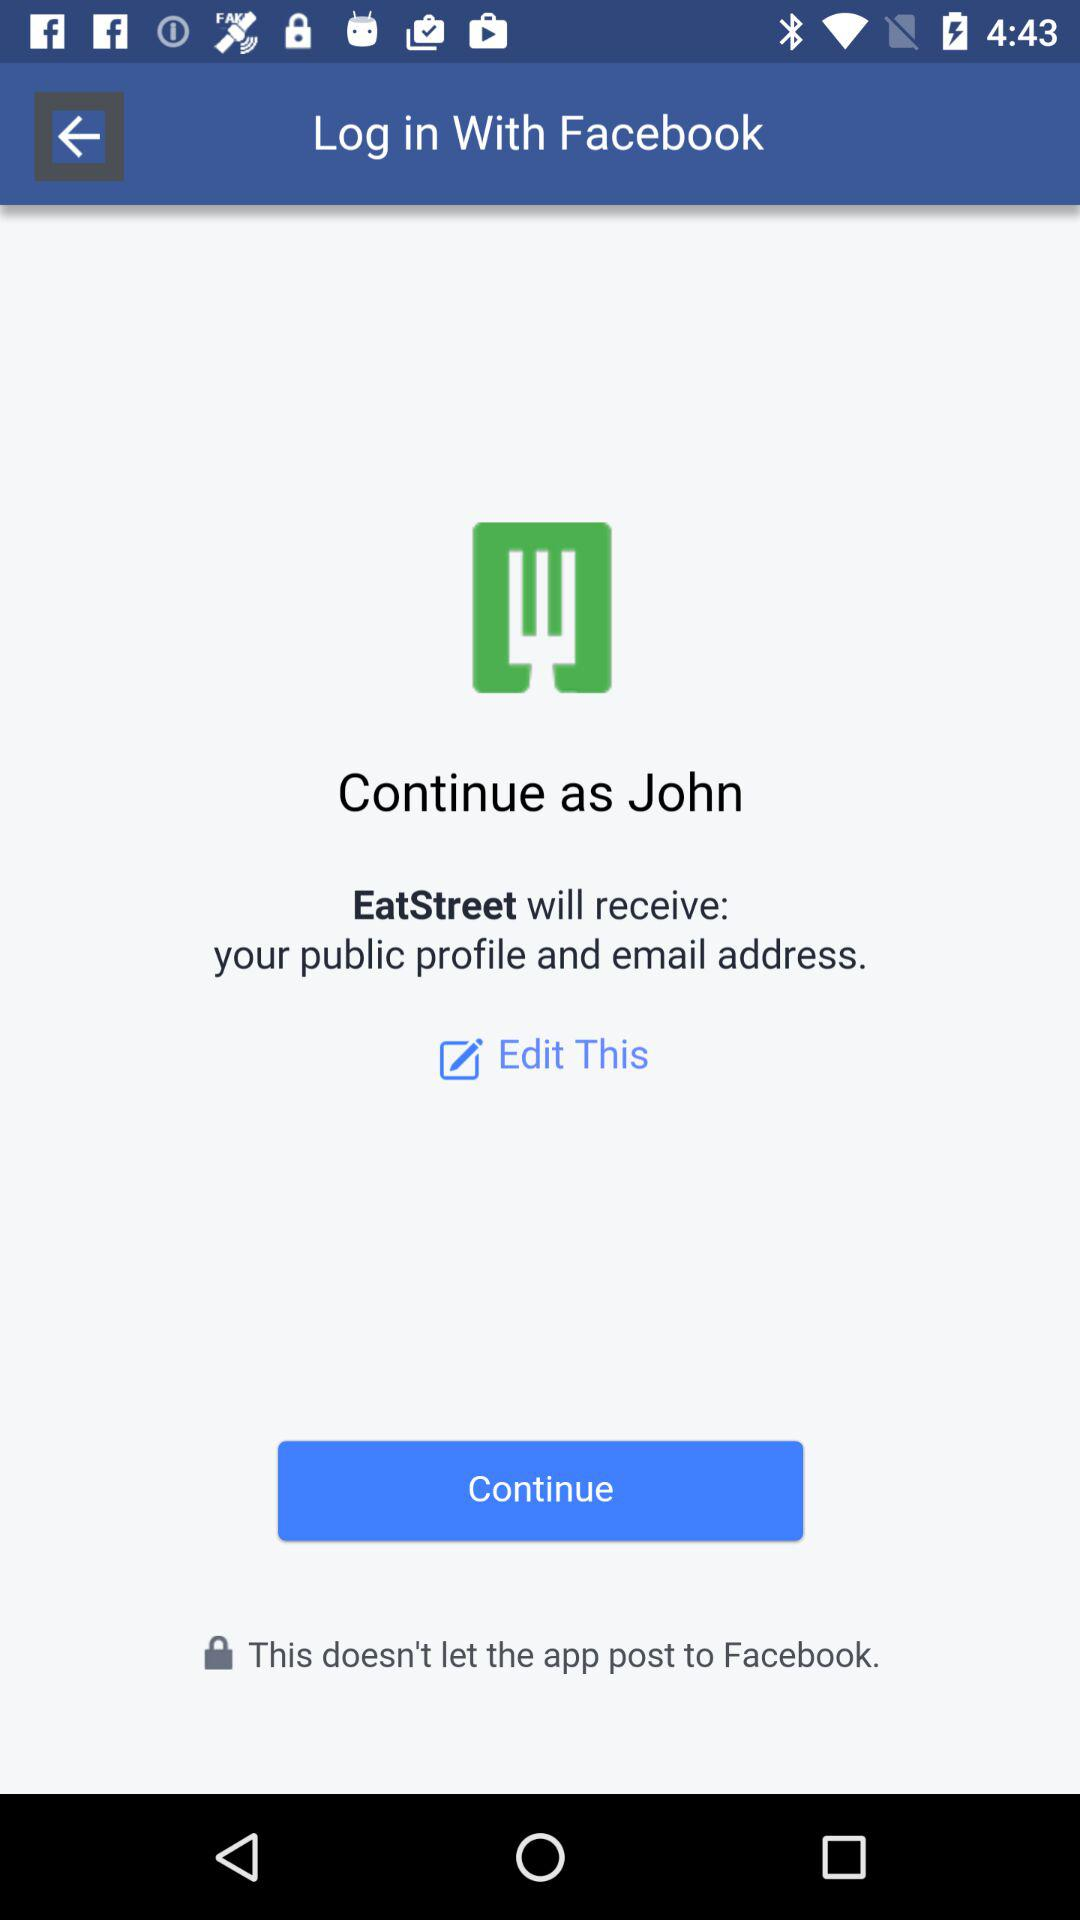What is the user name to continue on the login page? The user name is John. 